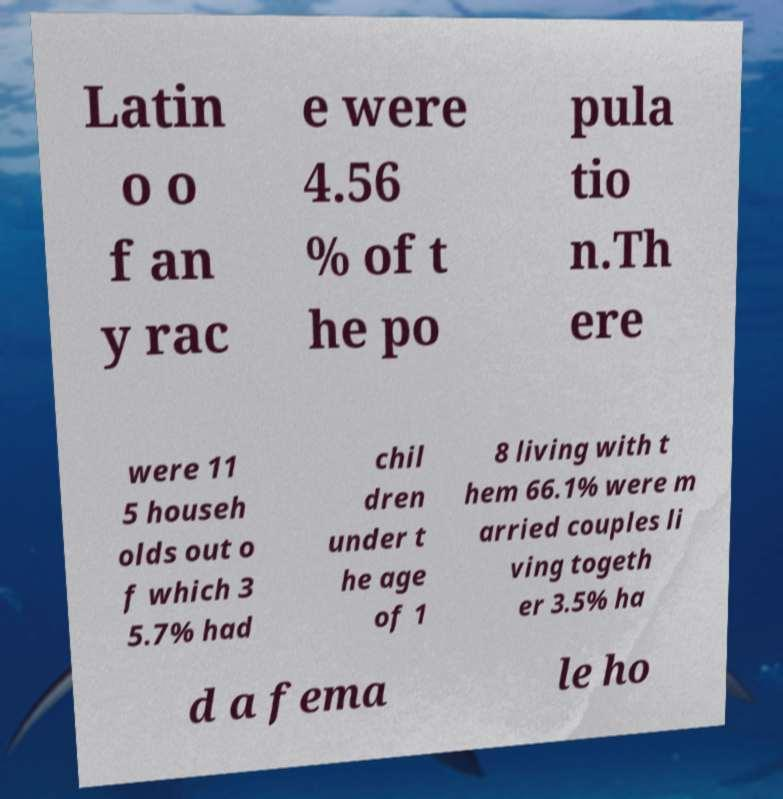Please identify and transcribe the text found in this image. Latin o o f an y rac e were 4.56 % of t he po pula tio n.Th ere were 11 5 househ olds out o f which 3 5.7% had chil dren under t he age of 1 8 living with t hem 66.1% were m arried couples li ving togeth er 3.5% ha d a fema le ho 